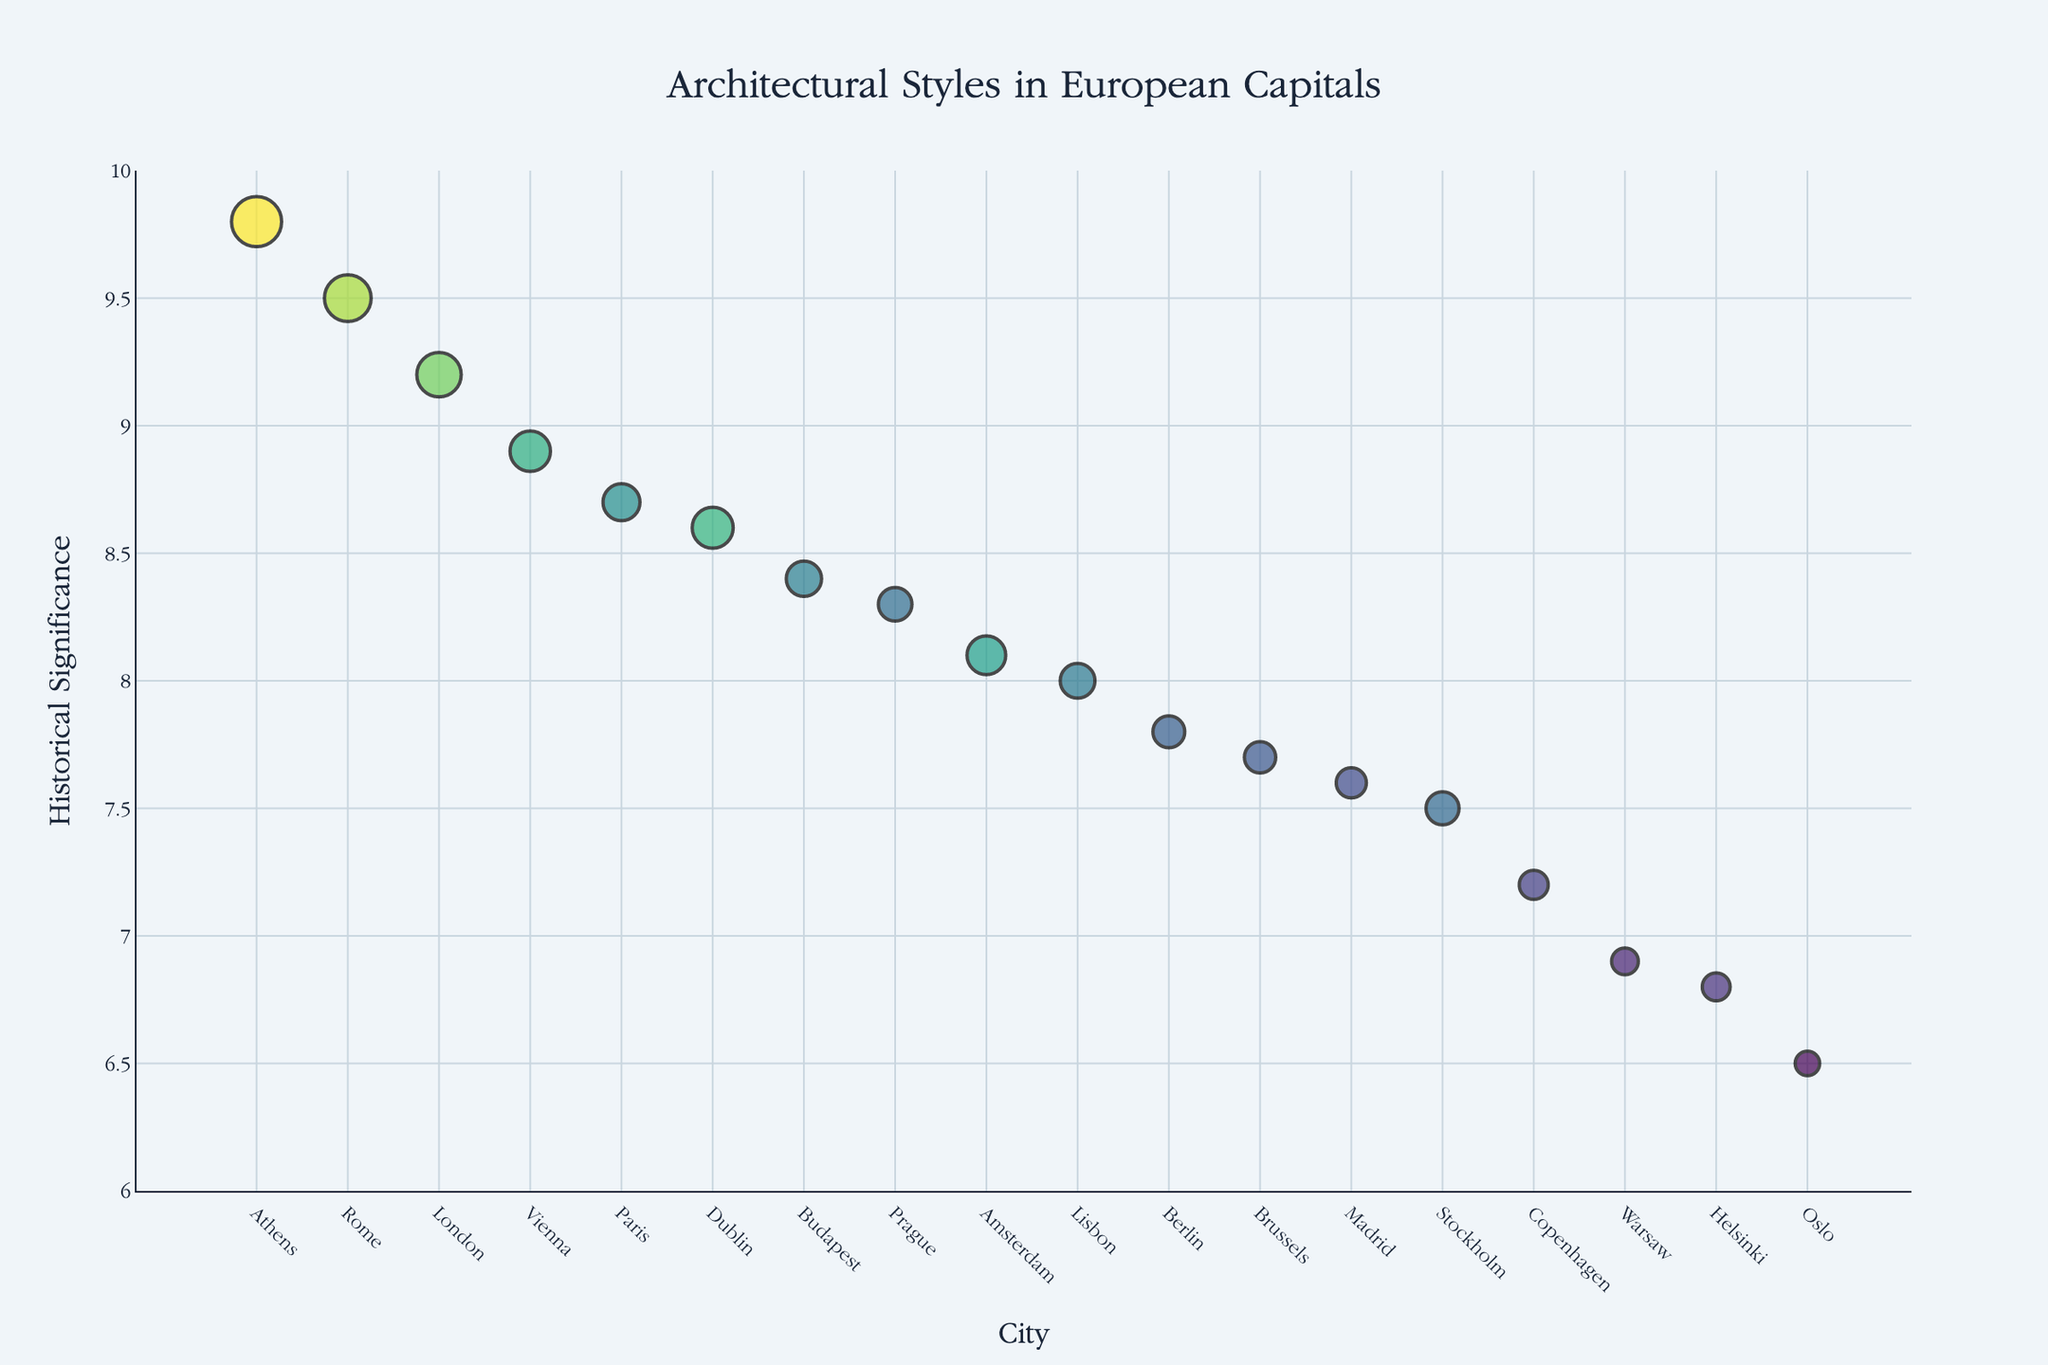Which city has the highest historical significance rating? The highest y-axis value represents historical significance, and the city corresponding to the highest point is Athens with a rating of 9.8.
Answer: Athens Which architectural style in Rome has a historical significance rating of 9.5? Find the city "Rome" on the x-axis and look at its corresponding y-value on the figure. The hover text will show that the style is "Renaissance" with a significance of 9.5.
Answer: Renaissance Which city has the least prevalent architectural style? Look for the smallest marker on the plot, representing the smallest prevalence. The smallest marker corresponds to Oslo.
Answer: Oslo What is the difference in historical significance rating between Georgian architecture in Dublin and Baroque architecture in Paris? Find Dublin and Paris on the x-axis. Dublin has a significance of 8.6, and Paris has a significance of 8.7. Their difference is 8.7 - 8.6 = 0.1.
Answer: 0.1 Which architectural style has a prevalence of 78 and in which city is it found? Locate the marker with size closest to 78, the hover text shows Gothic style in London.
Answer: Gothic, London Is the prevalence of the Neo-Gothic architectural style in Budapest greater than that of the Dutch Renaissance in Amsterdam? Find Budapest (Neo-Gothic) and Amsterdam (Dutch Renaissance) on the plot. Compare the marker sizes; Budapest has 62, and Amsterdam has 68. Thus, 62 is less than 68.
Answer: No What is the average historical significance rating of the architectural styles in Paris, Berlin, and Amsterdam? Add the significance ratings of Paris (8.7), Berlin (7.8), and Amsterdam (8.1). Average = (8.7 + 7.8 + 8.1) / 3 = 8.2.
Answer: 8.2 Which city has a historical significance rating closest to the median of all the cities? First, list the historical significance ratings and find the median: sorted ratings (6.5, 6.8, 6.9, 7.2, 7.5, 7.6, 7.7, 7.8, 8.0, 8.1, 8.3, 8.4, 8.6, 8.7, 8.9, 9.2, 9.5, 9.8), median is the middle value which is 8.1. Amsterdam matches this rating.
Answer: Amsterdam 